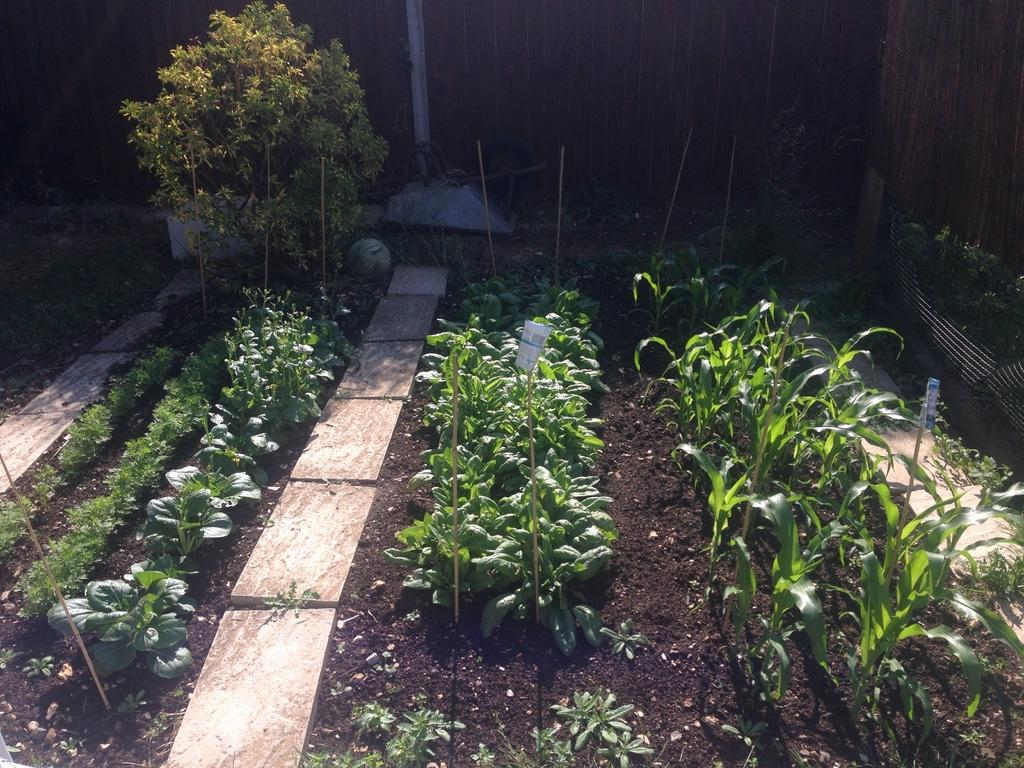What types of vegetation can be seen in the image? There are different types of plants in the image. How are the plants arranged in the image? The plants are planted in rows. What other type of vegetation is present in the image? There are trees in the image. What is the background element in the image? There is a wall in the image. How much wax is present on the plants in the image? There is no wax present on the plants in the image. What type of basket can be seen holding the plants in the image? There is no basket present in the image; the plants are planted in rows. 